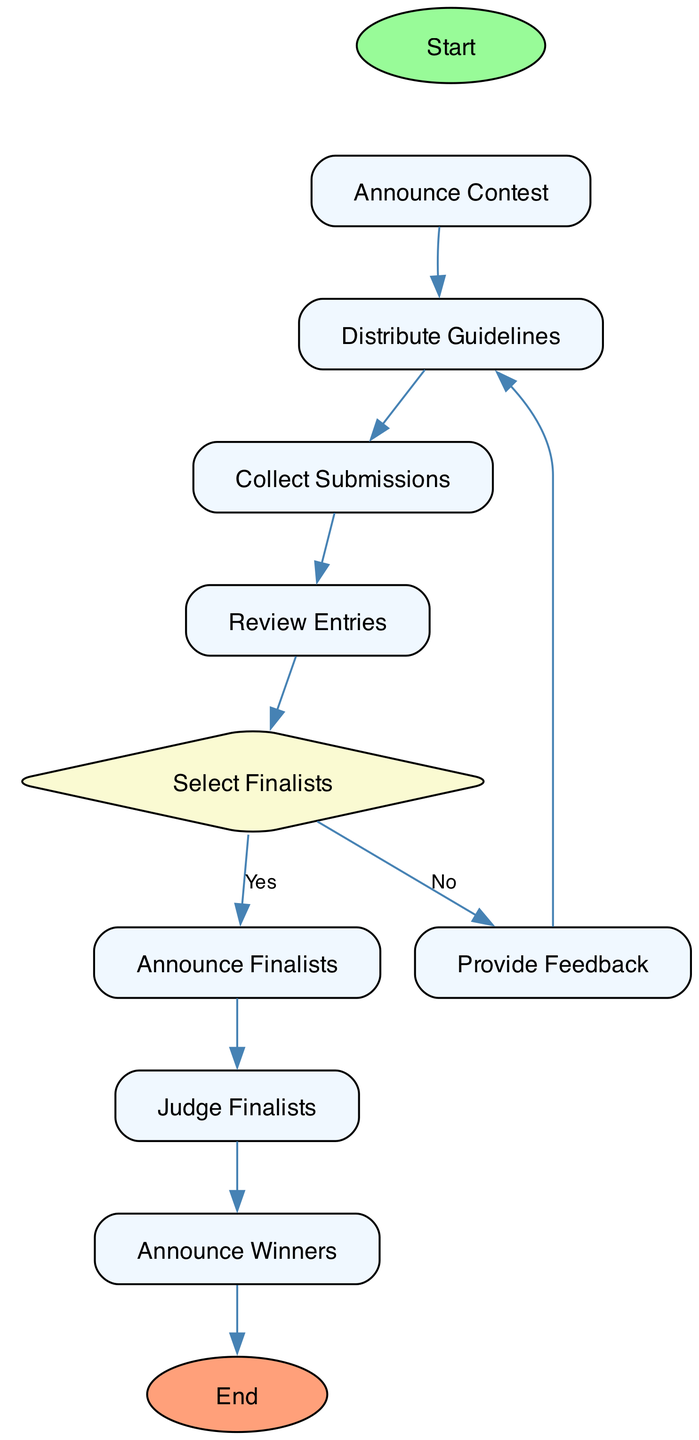What is the first step in organizing a writing contest? The first step in the flow chart is labeled "Start," which indicates the initiation of the contest organization process.
Answer: Start How many processes are there in the writing contest flow chart? By counting the nodes labeled as process (excluding start and end), there are six processes in the diagram: Announce Contest, Distribute Guidelines, Collect Submissions, Review Entries, Judge Finalists, and Announce Winners.
Answer: Six What happens if finalists are not selected? If finalists are not selected as per the decision node, the process leads to "Provide Feedback," which indicates giving constructive feedback to students.
Answer: Provide Feedback Who reviews the entries to determine winners? According to the diagram, the entries are reviewed by a panel of judges, which typically includes teachers or guest authors to determine the contest winners.
Answer: Panel of judges What is the final step in the process? The final step, labeled as "End," indicates the conclusion of the writing contest and encourages students to reflect on their writing experiences.
Answer: End How many decision points are in the flow chart? The diagram contains one decision point, which is at the "Select Finalists" node where the decision splits into two paths: yes and no.
Answer: One What action follows after "Announce Finalists"? Following the "Announce Finalists," the next action in the flow chart is "Judge Finalists," where judges evaluate the group of selected entries.
Answer: Judge Finalists What is the purpose of the "Review Entries" process? The purpose of the "Review Entries" process is to evaluate writing submissions based on specified criteria like creativity, grammar, and adherence to the theme, which is essential for selecting quality finalists.
Answer: Evaluate submissions 